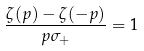<formula> <loc_0><loc_0><loc_500><loc_500>\frac { \zeta ( p ) - \zeta ( - p ) } { p \sigma _ { + } } = 1</formula> 